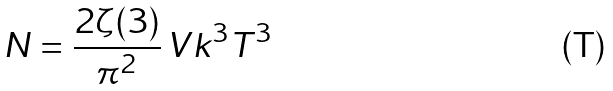Convert formula to latex. <formula><loc_0><loc_0><loc_500><loc_500>N = \frac { 2 \zeta ( 3 ) } { \pi ^ { 2 } } \, V k ^ { 3 } T ^ { 3 }</formula> 